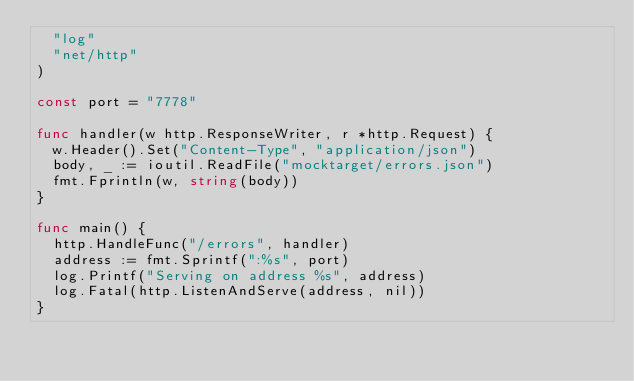Convert code to text. <code><loc_0><loc_0><loc_500><loc_500><_Go_>	"log"
	"net/http"
)

const port = "7778"

func handler(w http.ResponseWriter, r *http.Request) {
	w.Header().Set("Content-Type", "application/json")
	body, _ := ioutil.ReadFile("mocktarget/errors.json")
	fmt.Fprintln(w, string(body))
}

func main() {
	http.HandleFunc("/errors", handler)
	address := fmt.Sprintf(":%s", port)
	log.Printf("Serving on address %s", address)
	log.Fatal(http.ListenAndServe(address, nil))
}
</code> 